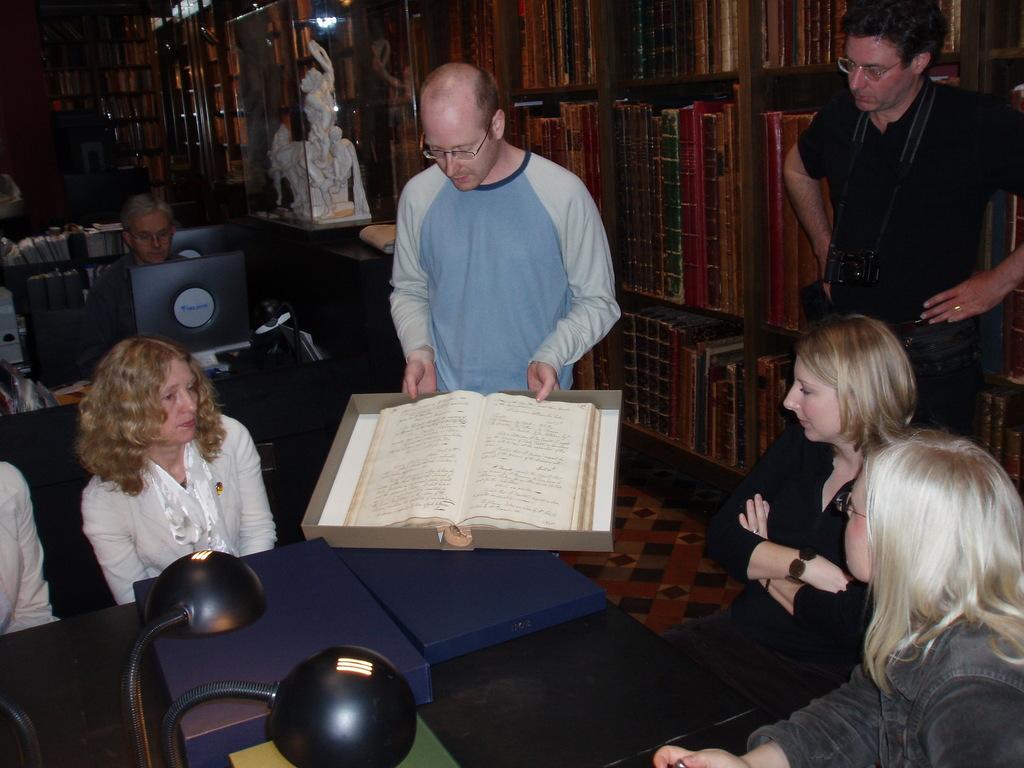Can you describe this image briefly? In this picture there and number of people discussing regarding some book, it looks like library with number of books in the cabinets, person in the background is sitting and working on the laptop and there is statue in the upper middle picture. 